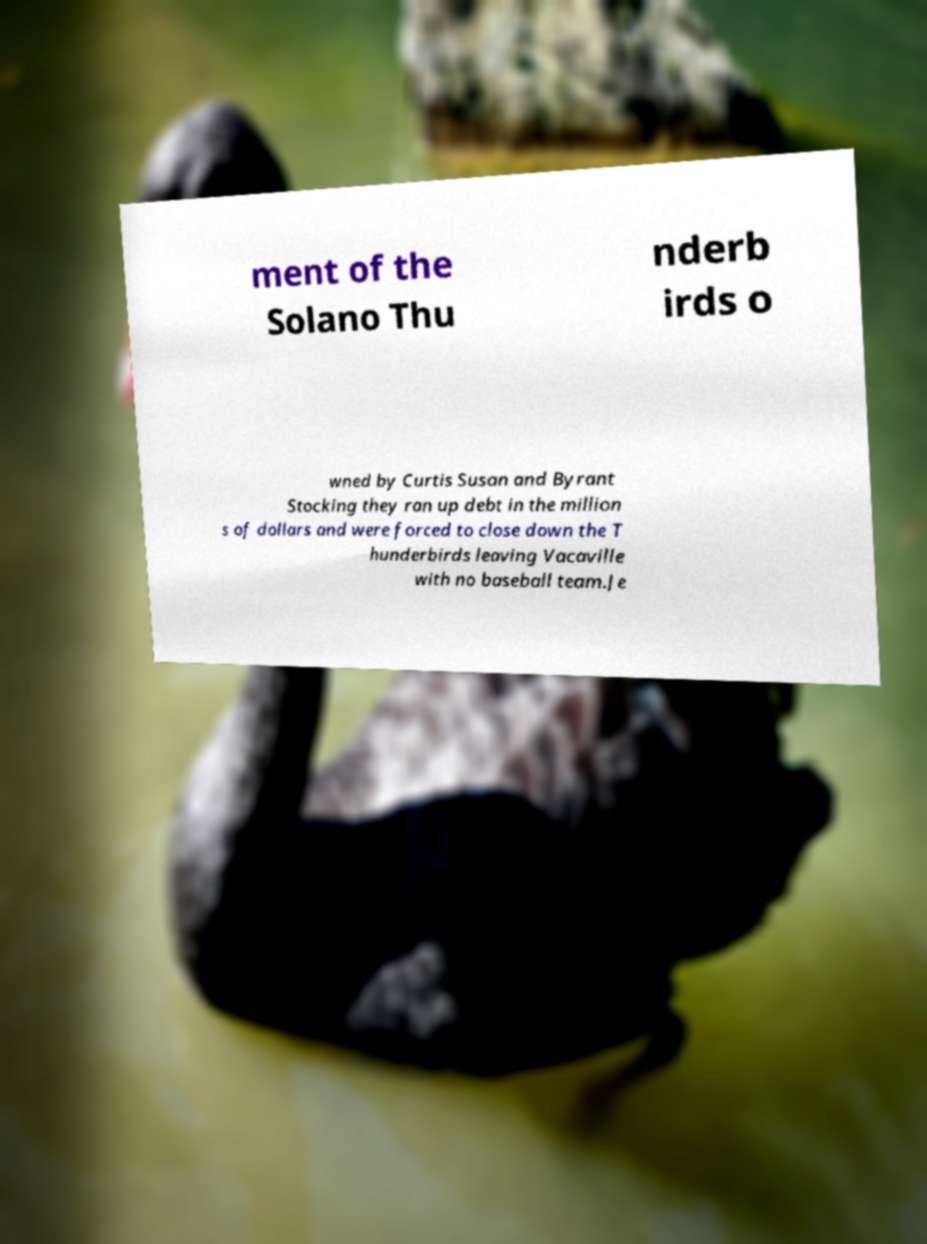Could you extract and type out the text from this image? ment of the Solano Thu nderb irds o wned by Curtis Susan and Byrant Stocking they ran up debt in the million s of dollars and were forced to close down the T hunderbirds leaving Vacaville with no baseball team.Je 